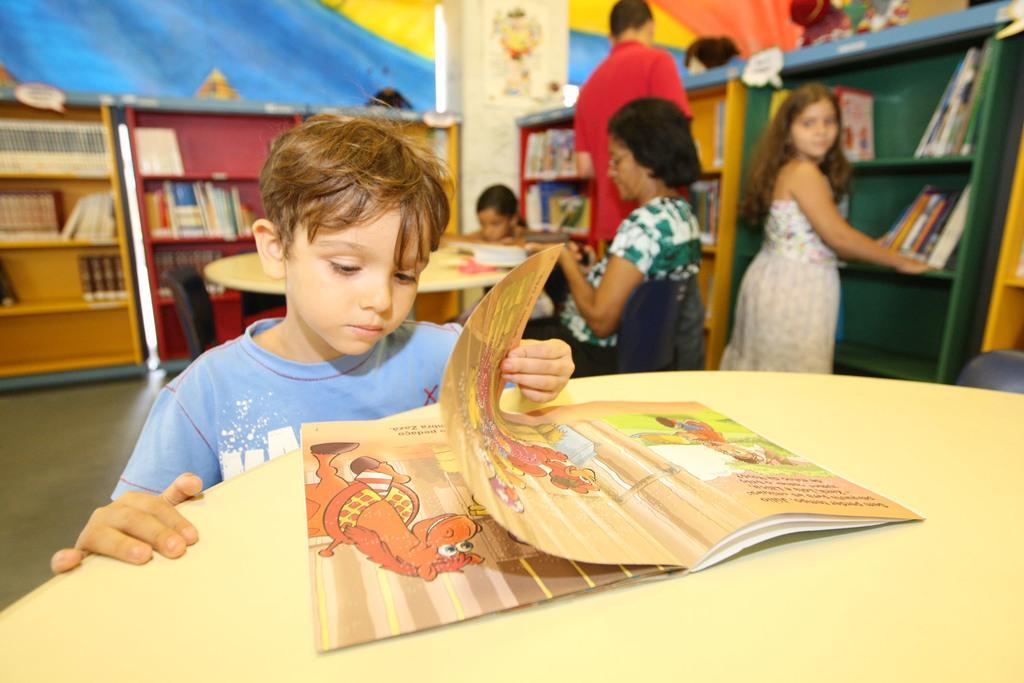Could you give a brief overview of what you see in this image? In this image in the front there is a table and on the table there is a book, behind the table there is a boy holding a book in his hand. In the background there are persons standing and sitting, there are shelves and there are books in the shelves and there is a table and on the table, there are books and there are empty chairs. In the background there is a wall and on the wall there is a painting. 